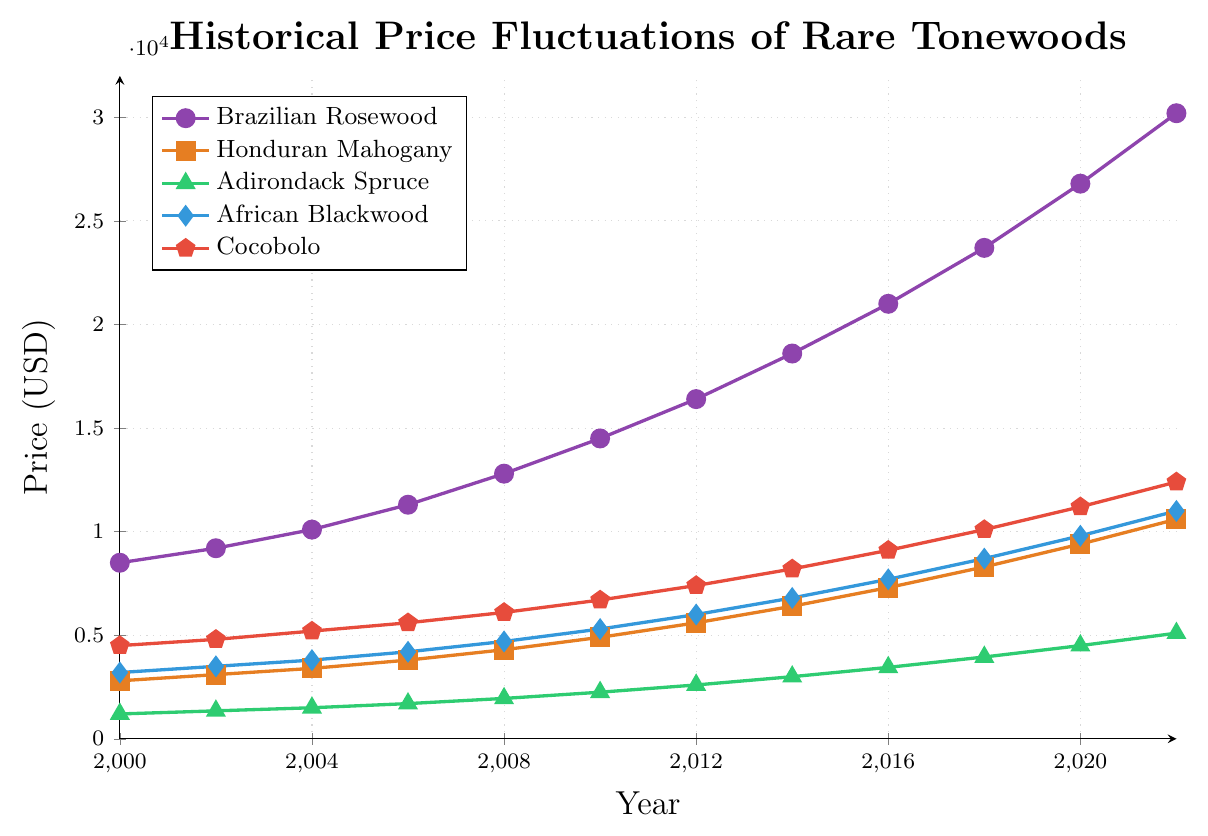Which tonewood had the highest price in 2022? By inspecting the chart for the year 2022, we see Brazilian Rosewood ($30200) is the highest.
Answer: Brazilian Rosewood What was the price difference between African Blackwood and Cocobolo in 2010? For 2010, African Blackwood is at $5300 and Cocobolo at $6700. The difference is $6700 - $5300.
Answer: $1400 Which tonewood experienced the steepest price increase from 2000 to 2022? By comparing price increases for all tonewoods from 2000 to 2022, Brazilian Rosewood increased from $8500 to $30200 ($8500 to $30200, increase of $21700), which is the steepest.
Answer: Brazilian Rosewood On average, how much did the price of Adirondack Spruce increase per year from 2000 to 2022? The total price increase for Adirondack Spruce from 2000 to 2022 is $5100 - $1200 = $3900. Dividing this by the number of years (22) gives the average annual increase.
Answer: $177.27 If you combine the prices of Honduran Mahogany and Cocobolo in 2022, how much would it be? Adding the prices for these two tonewoods in 2022: Honduran Mahogany ($10600) + Cocobolo ($12400).
Answer: $23000 During which period did Brazilian Rosewood experience the largest change in absolute price? By examining year-to-year changes, the largest change is from 2018 ($23700) to 2020 ($26800), a difference of $3100.
Answer: 2018 to 2020 How does the price of Honduran Mahogany in 2018 compare to its price in 2006? In 2018, Honduran Mahogany is priced at $8300 and in 2006 at $3800. Comparing the two shows that 2018 is higher.
Answer: 2018 is higher What is the price trend for Cocobolo between 2014 and 2020? Observing the chart, Cocobolo increases from $8200 in 2014 to $12400 in 2020. This indicates an upward trend.
Answer: Upward trend Which tonewood had the least price increase from 2000 to 2010? Comparisons show Adirondack Spruce increased the least from $1200 in 2000 to $2250 in 2010, a difference of $1050.
Answer: Adirondack Spruce Which tonewood's price surpassed $10,000 first, and in what year? Analyzing the chart, Brazilian Rosewood surpassed $10,000 first in 2004.
Answer: Brazilian Rosewood, 2004 